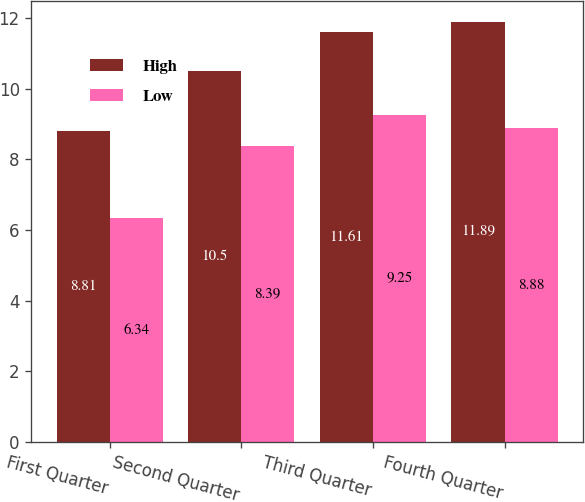<chart> <loc_0><loc_0><loc_500><loc_500><stacked_bar_chart><ecel><fcel>First Quarter<fcel>Second Quarter<fcel>Third Quarter<fcel>Fourth Quarter<nl><fcel>High<fcel>8.81<fcel>10.5<fcel>11.61<fcel>11.89<nl><fcel>Low<fcel>6.34<fcel>8.39<fcel>9.25<fcel>8.88<nl></chart> 